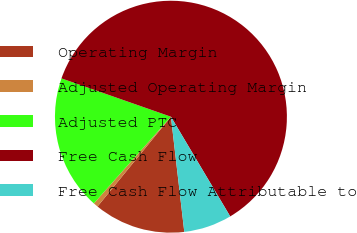Convert chart to OTSL. <chart><loc_0><loc_0><loc_500><loc_500><pie_chart><fcel>Operating Margin<fcel>Adjusted Operating Margin<fcel>Adjusted PTC<fcel>Free Cash Flow<fcel>Free Cash Flow Attributable to<nl><fcel>12.75%<fcel>0.66%<fcel>18.79%<fcel>61.1%<fcel>6.7%<nl></chart> 